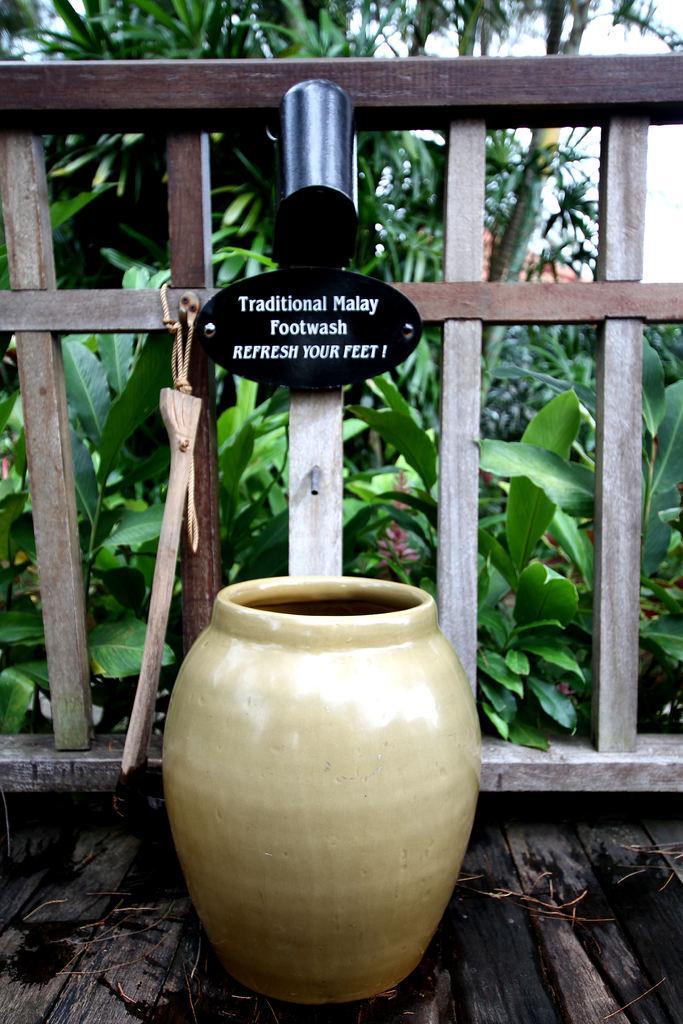How would you summarize this image in a sentence or two? In this image we can see a container on the wooden surface. There are many plants in the image. There is a board on which some text written on it. 